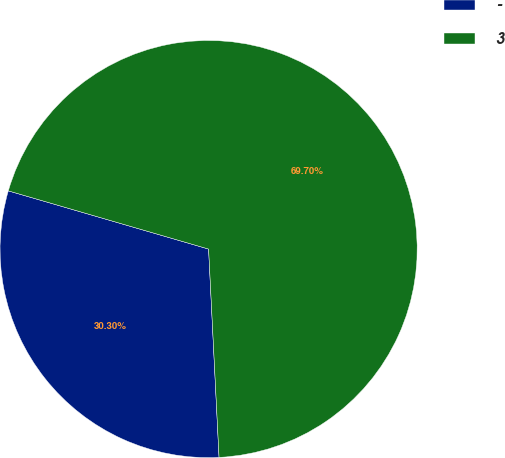Convert chart. <chart><loc_0><loc_0><loc_500><loc_500><pie_chart><fcel>-<fcel>3<nl><fcel>30.3%<fcel>69.7%<nl></chart> 